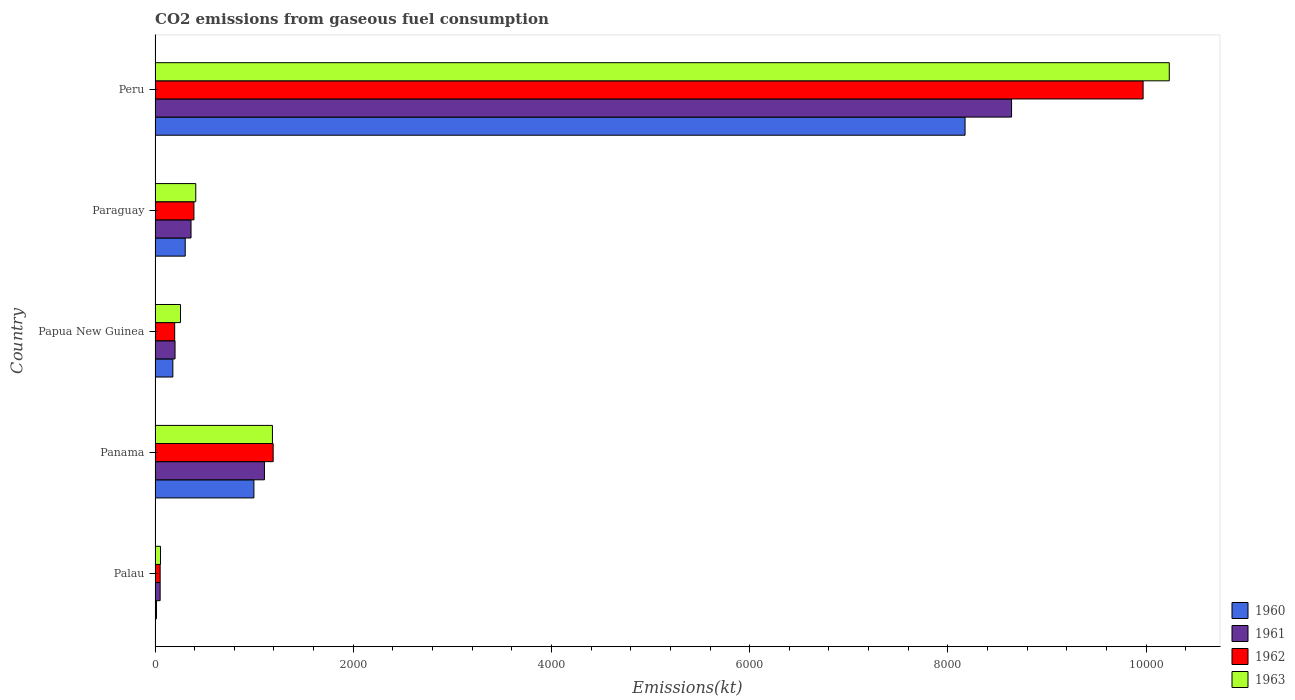Are the number of bars on each tick of the Y-axis equal?
Offer a terse response. Yes. How many bars are there on the 1st tick from the top?
Make the answer very short. 4. How many bars are there on the 4th tick from the bottom?
Offer a very short reply. 4. What is the label of the 4th group of bars from the top?
Your answer should be compact. Panama. What is the amount of CO2 emitted in 1960 in Peru?
Give a very brief answer. 8173.74. Across all countries, what is the maximum amount of CO2 emitted in 1962?
Provide a short and direct response. 9970.57. Across all countries, what is the minimum amount of CO2 emitted in 1963?
Offer a terse response. 55.01. In which country was the amount of CO2 emitted in 1961 maximum?
Your answer should be compact. Peru. In which country was the amount of CO2 emitted in 1961 minimum?
Your answer should be compact. Palau. What is the total amount of CO2 emitted in 1963 in the graph?
Provide a short and direct response. 1.21e+04. What is the difference between the amount of CO2 emitted in 1961 in Palau and that in Papua New Guinea?
Keep it short and to the point. -150.35. What is the difference between the amount of CO2 emitted in 1960 in Palau and the amount of CO2 emitted in 1962 in Peru?
Keep it short and to the point. -9955.91. What is the average amount of CO2 emitted in 1963 per country?
Make the answer very short. 2428.29. What is the difference between the amount of CO2 emitted in 1963 and amount of CO2 emitted in 1961 in Panama?
Ensure brevity in your answer.  80.67. In how many countries, is the amount of CO2 emitted in 1961 greater than 1600 kt?
Offer a very short reply. 1. What is the ratio of the amount of CO2 emitted in 1962 in Panama to that in Paraguay?
Make the answer very short. 3.04. Is the difference between the amount of CO2 emitted in 1963 in Panama and Papua New Guinea greater than the difference between the amount of CO2 emitted in 1961 in Panama and Papua New Guinea?
Provide a succinct answer. Yes. What is the difference between the highest and the second highest amount of CO2 emitted in 1963?
Offer a very short reply. 9050.16. What is the difference between the highest and the lowest amount of CO2 emitted in 1961?
Your answer should be very brief. 8591.78. Is the sum of the amount of CO2 emitted in 1961 in Palau and Peru greater than the maximum amount of CO2 emitted in 1963 across all countries?
Provide a succinct answer. No. What does the 4th bar from the top in Palau represents?
Give a very brief answer. 1960. Is it the case that in every country, the sum of the amount of CO2 emitted in 1961 and amount of CO2 emitted in 1962 is greater than the amount of CO2 emitted in 1963?
Keep it short and to the point. Yes. Are all the bars in the graph horizontal?
Make the answer very short. Yes. How many countries are there in the graph?
Offer a terse response. 5. Are the values on the major ticks of X-axis written in scientific E-notation?
Offer a terse response. No. Does the graph contain grids?
Provide a succinct answer. No. How many legend labels are there?
Provide a succinct answer. 4. What is the title of the graph?
Your answer should be compact. CO2 emissions from gaseous fuel consumption. Does "1982" appear as one of the legend labels in the graph?
Provide a succinct answer. No. What is the label or title of the X-axis?
Offer a very short reply. Emissions(kt). What is the label or title of the Y-axis?
Offer a terse response. Country. What is the Emissions(kt) in 1960 in Palau?
Your answer should be very brief. 14.67. What is the Emissions(kt) of 1961 in Palau?
Give a very brief answer. 51.34. What is the Emissions(kt) of 1962 in Palau?
Offer a terse response. 51.34. What is the Emissions(kt) in 1963 in Palau?
Give a very brief answer. 55.01. What is the Emissions(kt) in 1960 in Panama?
Your answer should be very brief. 997.42. What is the Emissions(kt) of 1961 in Panama?
Give a very brief answer. 1103.77. What is the Emissions(kt) of 1962 in Panama?
Provide a succinct answer. 1191.78. What is the Emissions(kt) of 1963 in Panama?
Your response must be concise. 1184.44. What is the Emissions(kt) in 1960 in Papua New Guinea?
Your answer should be compact. 179.68. What is the Emissions(kt) of 1961 in Papua New Guinea?
Make the answer very short. 201.69. What is the Emissions(kt) in 1962 in Papua New Guinea?
Keep it short and to the point. 198.02. What is the Emissions(kt) of 1963 in Papua New Guinea?
Keep it short and to the point. 256.69. What is the Emissions(kt) in 1960 in Paraguay?
Offer a very short reply. 304.36. What is the Emissions(kt) of 1961 in Paraguay?
Offer a very short reply. 363.03. What is the Emissions(kt) of 1962 in Paraguay?
Make the answer very short. 392.37. What is the Emissions(kt) of 1963 in Paraguay?
Your answer should be very brief. 410.7. What is the Emissions(kt) in 1960 in Peru?
Make the answer very short. 8173.74. What is the Emissions(kt) of 1961 in Peru?
Your answer should be very brief. 8643.12. What is the Emissions(kt) of 1962 in Peru?
Your response must be concise. 9970.57. What is the Emissions(kt) of 1963 in Peru?
Give a very brief answer. 1.02e+04. Across all countries, what is the maximum Emissions(kt) in 1960?
Your answer should be very brief. 8173.74. Across all countries, what is the maximum Emissions(kt) of 1961?
Give a very brief answer. 8643.12. Across all countries, what is the maximum Emissions(kt) of 1962?
Keep it short and to the point. 9970.57. Across all countries, what is the maximum Emissions(kt) of 1963?
Make the answer very short. 1.02e+04. Across all countries, what is the minimum Emissions(kt) of 1960?
Offer a terse response. 14.67. Across all countries, what is the minimum Emissions(kt) in 1961?
Provide a short and direct response. 51.34. Across all countries, what is the minimum Emissions(kt) of 1962?
Your response must be concise. 51.34. Across all countries, what is the minimum Emissions(kt) in 1963?
Offer a terse response. 55.01. What is the total Emissions(kt) in 1960 in the graph?
Provide a succinct answer. 9669.88. What is the total Emissions(kt) in 1961 in the graph?
Your answer should be very brief. 1.04e+04. What is the total Emissions(kt) of 1962 in the graph?
Your answer should be compact. 1.18e+04. What is the total Emissions(kt) of 1963 in the graph?
Provide a short and direct response. 1.21e+04. What is the difference between the Emissions(kt) of 1960 in Palau and that in Panama?
Give a very brief answer. -982.76. What is the difference between the Emissions(kt) of 1961 in Palau and that in Panama?
Provide a short and direct response. -1052.43. What is the difference between the Emissions(kt) in 1962 in Palau and that in Panama?
Your answer should be compact. -1140.44. What is the difference between the Emissions(kt) in 1963 in Palau and that in Panama?
Give a very brief answer. -1129.44. What is the difference between the Emissions(kt) in 1960 in Palau and that in Papua New Guinea?
Keep it short and to the point. -165.01. What is the difference between the Emissions(kt) of 1961 in Palau and that in Papua New Guinea?
Offer a terse response. -150.35. What is the difference between the Emissions(kt) in 1962 in Palau and that in Papua New Guinea?
Make the answer very short. -146.68. What is the difference between the Emissions(kt) in 1963 in Palau and that in Papua New Guinea?
Provide a succinct answer. -201.69. What is the difference between the Emissions(kt) of 1960 in Palau and that in Paraguay?
Ensure brevity in your answer.  -289.69. What is the difference between the Emissions(kt) of 1961 in Palau and that in Paraguay?
Ensure brevity in your answer.  -311.69. What is the difference between the Emissions(kt) of 1962 in Palau and that in Paraguay?
Offer a terse response. -341.03. What is the difference between the Emissions(kt) in 1963 in Palau and that in Paraguay?
Ensure brevity in your answer.  -355.7. What is the difference between the Emissions(kt) of 1960 in Palau and that in Peru?
Offer a terse response. -8159.07. What is the difference between the Emissions(kt) of 1961 in Palau and that in Peru?
Provide a short and direct response. -8591.78. What is the difference between the Emissions(kt) in 1962 in Palau and that in Peru?
Provide a short and direct response. -9919.24. What is the difference between the Emissions(kt) of 1963 in Palau and that in Peru?
Keep it short and to the point. -1.02e+04. What is the difference between the Emissions(kt) of 1960 in Panama and that in Papua New Guinea?
Keep it short and to the point. 817.74. What is the difference between the Emissions(kt) in 1961 in Panama and that in Papua New Guinea?
Your response must be concise. 902.08. What is the difference between the Emissions(kt) in 1962 in Panama and that in Papua New Guinea?
Provide a succinct answer. 993.76. What is the difference between the Emissions(kt) in 1963 in Panama and that in Papua New Guinea?
Provide a succinct answer. 927.75. What is the difference between the Emissions(kt) in 1960 in Panama and that in Paraguay?
Offer a terse response. 693.06. What is the difference between the Emissions(kt) of 1961 in Panama and that in Paraguay?
Your answer should be very brief. 740.73. What is the difference between the Emissions(kt) of 1962 in Panama and that in Paraguay?
Offer a terse response. 799.41. What is the difference between the Emissions(kt) in 1963 in Panama and that in Paraguay?
Provide a short and direct response. 773.74. What is the difference between the Emissions(kt) in 1960 in Panama and that in Peru?
Provide a succinct answer. -7176.32. What is the difference between the Emissions(kt) of 1961 in Panama and that in Peru?
Make the answer very short. -7539.35. What is the difference between the Emissions(kt) in 1962 in Panama and that in Peru?
Make the answer very short. -8778.8. What is the difference between the Emissions(kt) in 1963 in Panama and that in Peru?
Provide a short and direct response. -9050.16. What is the difference between the Emissions(kt) in 1960 in Papua New Guinea and that in Paraguay?
Give a very brief answer. -124.68. What is the difference between the Emissions(kt) of 1961 in Papua New Guinea and that in Paraguay?
Your answer should be very brief. -161.35. What is the difference between the Emissions(kt) of 1962 in Papua New Guinea and that in Paraguay?
Keep it short and to the point. -194.35. What is the difference between the Emissions(kt) of 1963 in Papua New Guinea and that in Paraguay?
Ensure brevity in your answer.  -154.01. What is the difference between the Emissions(kt) in 1960 in Papua New Guinea and that in Peru?
Your response must be concise. -7994.06. What is the difference between the Emissions(kt) of 1961 in Papua New Guinea and that in Peru?
Ensure brevity in your answer.  -8441.43. What is the difference between the Emissions(kt) in 1962 in Papua New Guinea and that in Peru?
Provide a succinct answer. -9772.56. What is the difference between the Emissions(kt) in 1963 in Papua New Guinea and that in Peru?
Give a very brief answer. -9977.91. What is the difference between the Emissions(kt) of 1960 in Paraguay and that in Peru?
Provide a succinct answer. -7869.38. What is the difference between the Emissions(kt) of 1961 in Paraguay and that in Peru?
Make the answer very short. -8280.09. What is the difference between the Emissions(kt) in 1962 in Paraguay and that in Peru?
Your response must be concise. -9578.2. What is the difference between the Emissions(kt) in 1963 in Paraguay and that in Peru?
Provide a short and direct response. -9823.89. What is the difference between the Emissions(kt) of 1960 in Palau and the Emissions(kt) of 1961 in Panama?
Offer a terse response. -1089.1. What is the difference between the Emissions(kt) in 1960 in Palau and the Emissions(kt) in 1962 in Panama?
Your answer should be compact. -1177.11. What is the difference between the Emissions(kt) in 1960 in Palau and the Emissions(kt) in 1963 in Panama?
Give a very brief answer. -1169.77. What is the difference between the Emissions(kt) of 1961 in Palau and the Emissions(kt) of 1962 in Panama?
Your answer should be compact. -1140.44. What is the difference between the Emissions(kt) of 1961 in Palau and the Emissions(kt) of 1963 in Panama?
Your answer should be compact. -1133.1. What is the difference between the Emissions(kt) of 1962 in Palau and the Emissions(kt) of 1963 in Panama?
Your answer should be very brief. -1133.1. What is the difference between the Emissions(kt) in 1960 in Palau and the Emissions(kt) in 1961 in Papua New Guinea?
Your answer should be very brief. -187.02. What is the difference between the Emissions(kt) of 1960 in Palau and the Emissions(kt) of 1962 in Papua New Guinea?
Your answer should be compact. -183.35. What is the difference between the Emissions(kt) in 1960 in Palau and the Emissions(kt) in 1963 in Papua New Guinea?
Your response must be concise. -242.02. What is the difference between the Emissions(kt) of 1961 in Palau and the Emissions(kt) of 1962 in Papua New Guinea?
Make the answer very short. -146.68. What is the difference between the Emissions(kt) in 1961 in Palau and the Emissions(kt) in 1963 in Papua New Guinea?
Make the answer very short. -205.35. What is the difference between the Emissions(kt) of 1962 in Palau and the Emissions(kt) of 1963 in Papua New Guinea?
Ensure brevity in your answer.  -205.35. What is the difference between the Emissions(kt) in 1960 in Palau and the Emissions(kt) in 1961 in Paraguay?
Your response must be concise. -348.37. What is the difference between the Emissions(kt) of 1960 in Palau and the Emissions(kt) of 1962 in Paraguay?
Offer a very short reply. -377.7. What is the difference between the Emissions(kt) of 1960 in Palau and the Emissions(kt) of 1963 in Paraguay?
Offer a very short reply. -396.04. What is the difference between the Emissions(kt) of 1961 in Palau and the Emissions(kt) of 1962 in Paraguay?
Make the answer very short. -341.03. What is the difference between the Emissions(kt) in 1961 in Palau and the Emissions(kt) in 1963 in Paraguay?
Provide a succinct answer. -359.37. What is the difference between the Emissions(kt) in 1962 in Palau and the Emissions(kt) in 1963 in Paraguay?
Offer a terse response. -359.37. What is the difference between the Emissions(kt) of 1960 in Palau and the Emissions(kt) of 1961 in Peru?
Ensure brevity in your answer.  -8628.45. What is the difference between the Emissions(kt) in 1960 in Palau and the Emissions(kt) in 1962 in Peru?
Offer a terse response. -9955.91. What is the difference between the Emissions(kt) in 1960 in Palau and the Emissions(kt) in 1963 in Peru?
Your response must be concise. -1.02e+04. What is the difference between the Emissions(kt) in 1961 in Palau and the Emissions(kt) in 1962 in Peru?
Keep it short and to the point. -9919.24. What is the difference between the Emissions(kt) of 1961 in Palau and the Emissions(kt) of 1963 in Peru?
Your response must be concise. -1.02e+04. What is the difference between the Emissions(kt) in 1962 in Palau and the Emissions(kt) in 1963 in Peru?
Your answer should be very brief. -1.02e+04. What is the difference between the Emissions(kt) of 1960 in Panama and the Emissions(kt) of 1961 in Papua New Guinea?
Ensure brevity in your answer.  795.74. What is the difference between the Emissions(kt) of 1960 in Panama and the Emissions(kt) of 1962 in Papua New Guinea?
Make the answer very short. 799.41. What is the difference between the Emissions(kt) of 1960 in Panama and the Emissions(kt) of 1963 in Papua New Guinea?
Offer a terse response. 740.73. What is the difference between the Emissions(kt) of 1961 in Panama and the Emissions(kt) of 1962 in Papua New Guinea?
Ensure brevity in your answer.  905.75. What is the difference between the Emissions(kt) of 1961 in Panama and the Emissions(kt) of 1963 in Papua New Guinea?
Offer a terse response. 847.08. What is the difference between the Emissions(kt) of 1962 in Panama and the Emissions(kt) of 1963 in Papua New Guinea?
Make the answer very short. 935.09. What is the difference between the Emissions(kt) in 1960 in Panama and the Emissions(kt) in 1961 in Paraguay?
Provide a succinct answer. 634.39. What is the difference between the Emissions(kt) of 1960 in Panama and the Emissions(kt) of 1962 in Paraguay?
Give a very brief answer. 605.05. What is the difference between the Emissions(kt) of 1960 in Panama and the Emissions(kt) of 1963 in Paraguay?
Provide a short and direct response. 586.72. What is the difference between the Emissions(kt) in 1961 in Panama and the Emissions(kt) in 1962 in Paraguay?
Your answer should be very brief. 711.4. What is the difference between the Emissions(kt) of 1961 in Panama and the Emissions(kt) of 1963 in Paraguay?
Offer a terse response. 693.06. What is the difference between the Emissions(kt) of 1962 in Panama and the Emissions(kt) of 1963 in Paraguay?
Your answer should be compact. 781.07. What is the difference between the Emissions(kt) in 1960 in Panama and the Emissions(kt) in 1961 in Peru?
Provide a succinct answer. -7645.69. What is the difference between the Emissions(kt) of 1960 in Panama and the Emissions(kt) of 1962 in Peru?
Offer a very short reply. -8973.15. What is the difference between the Emissions(kt) in 1960 in Panama and the Emissions(kt) in 1963 in Peru?
Provide a succinct answer. -9237.17. What is the difference between the Emissions(kt) of 1961 in Panama and the Emissions(kt) of 1962 in Peru?
Your answer should be very brief. -8866.81. What is the difference between the Emissions(kt) of 1961 in Panama and the Emissions(kt) of 1963 in Peru?
Keep it short and to the point. -9130.83. What is the difference between the Emissions(kt) of 1962 in Panama and the Emissions(kt) of 1963 in Peru?
Ensure brevity in your answer.  -9042.82. What is the difference between the Emissions(kt) of 1960 in Papua New Guinea and the Emissions(kt) of 1961 in Paraguay?
Provide a succinct answer. -183.35. What is the difference between the Emissions(kt) in 1960 in Papua New Guinea and the Emissions(kt) in 1962 in Paraguay?
Your answer should be compact. -212.69. What is the difference between the Emissions(kt) in 1960 in Papua New Guinea and the Emissions(kt) in 1963 in Paraguay?
Your answer should be very brief. -231.02. What is the difference between the Emissions(kt) in 1961 in Papua New Guinea and the Emissions(kt) in 1962 in Paraguay?
Your answer should be very brief. -190.68. What is the difference between the Emissions(kt) of 1961 in Papua New Guinea and the Emissions(kt) of 1963 in Paraguay?
Your response must be concise. -209.02. What is the difference between the Emissions(kt) in 1962 in Papua New Guinea and the Emissions(kt) in 1963 in Paraguay?
Keep it short and to the point. -212.69. What is the difference between the Emissions(kt) in 1960 in Papua New Guinea and the Emissions(kt) in 1961 in Peru?
Make the answer very short. -8463.44. What is the difference between the Emissions(kt) of 1960 in Papua New Guinea and the Emissions(kt) of 1962 in Peru?
Give a very brief answer. -9790.89. What is the difference between the Emissions(kt) in 1960 in Papua New Guinea and the Emissions(kt) in 1963 in Peru?
Make the answer very short. -1.01e+04. What is the difference between the Emissions(kt) of 1961 in Papua New Guinea and the Emissions(kt) of 1962 in Peru?
Ensure brevity in your answer.  -9768.89. What is the difference between the Emissions(kt) in 1961 in Papua New Guinea and the Emissions(kt) in 1963 in Peru?
Ensure brevity in your answer.  -1.00e+04. What is the difference between the Emissions(kt) in 1962 in Papua New Guinea and the Emissions(kt) in 1963 in Peru?
Ensure brevity in your answer.  -1.00e+04. What is the difference between the Emissions(kt) of 1960 in Paraguay and the Emissions(kt) of 1961 in Peru?
Offer a terse response. -8338.76. What is the difference between the Emissions(kt) in 1960 in Paraguay and the Emissions(kt) in 1962 in Peru?
Offer a terse response. -9666.21. What is the difference between the Emissions(kt) of 1960 in Paraguay and the Emissions(kt) of 1963 in Peru?
Give a very brief answer. -9930.24. What is the difference between the Emissions(kt) in 1961 in Paraguay and the Emissions(kt) in 1962 in Peru?
Offer a terse response. -9607.54. What is the difference between the Emissions(kt) of 1961 in Paraguay and the Emissions(kt) of 1963 in Peru?
Make the answer very short. -9871.56. What is the difference between the Emissions(kt) of 1962 in Paraguay and the Emissions(kt) of 1963 in Peru?
Provide a succinct answer. -9842.23. What is the average Emissions(kt) in 1960 per country?
Give a very brief answer. 1933.98. What is the average Emissions(kt) of 1961 per country?
Your response must be concise. 2072.59. What is the average Emissions(kt) of 1962 per country?
Give a very brief answer. 2360.81. What is the average Emissions(kt) in 1963 per country?
Provide a succinct answer. 2428.29. What is the difference between the Emissions(kt) in 1960 and Emissions(kt) in 1961 in Palau?
Offer a terse response. -36.67. What is the difference between the Emissions(kt) of 1960 and Emissions(kt) of 1962 in Palau?
Make the answer very short. -36.67. What is the difference between the Emissions(kt) of 1960 and Emissions(kt) of 1963 in Palau?
Your answer should be compact. -40.34. What is the difference between the Emissions(kt) in 1961 and Emissions(kt) in 1963 in Palau?
Ensure brevity in your answer.  -3.67. What is the difference between the Emissions(kt) of 1962 and Emissions(kt) of 1963 in Palau?
Provide a short and direct response. -3.67. What is the difference between the Emissions(kt) of 1960 and Emissions(kt) of 1961 in Panama?
Give a very brief answer. -106.34. What is the difference between the Emissions(kt) of 1960 and Emissions(kt) of 1962 in Panama?
Keep it short and to the point. -194.35. What is the difference between the Emissions(kt) in 1960 and Emissions(kt) in 1963 in Panama?
Ensure brevity in your answer.  -187.02. What is the difference between the Emissions(kt) of 1961 and Emissions(kt) of 1962 in Panama?
Keep it short and to the point. -88.01. What is the difference between the Emissions(kt) in 1961 and Emissions(kt) in 1963 in Panama?
Your response must be concise. -80.67. What is the difference between the Emissions(kt) in 1962 and Emissions(kt) in 1963 in Panama?
Provide a short and direct response. 7.33. What is the difference between the Emissions(kt) of 1960 and Emissions(kt) of 1961 in Papua New Guinea?
Your response must be concise. -22. What is the difference between the Emissions(kt) in 1960 and Emissions(kt) in 1962 in Papua New Guinea?
Give a very brief answer. -18.34. What is the difference between the Emissions(kt) in 1960 and Emissions(kt) in 1963 in Papua New Guinea?
Make the answer very short. -77.01. What is the difference between the Emissions(kt) of 1961 and Emissions(kt) of 1962 in Papua New Guinea?
Your answer should be compact. 3.67. What is the difference between the Emissions(kt) of 1961 and Emissions(kt) of 1963 in Papua New Guinea?
Offer a terse response. -55.01. What is the difference between the Emissions(kt) in 1962 and Emissions(kt) in 1963 in Papua New Guinea?
Your response must be concise. -58.67. What is the difference between the Emissions(kt) of 1960 and Emissions(kt) of 1961 in Paraguay?
Your response must be concise. -58.67. What is the difference between the Emissions(kt) in 1960 and Emissions(kt) in 1962 in Paraguay?
Provide a short and direct response. -88.01. What is the difference between the Emissions(kt) of 1960 and Emissions(kt) of 1963 in Paraguay?
Ensure brevity in your answer.  -106.34. What is the difference between the Emissions(kt) in 1961 and Emissions(kt) in 1962 in Paraguay?
Give a very brief answer. -29.34. What is the difference between the Emissions(kt) in 1961 and Emissions(kt) in 1963 in Paraguay?
Offer a very short reply. -47.67. What is the difference between the Emissions(kt) of 1962 and Emissions(kt) of 1963 in Paraguay?
Keep it short and to the point. -18.34. What is the difference between the Emissions(kt) in 1960 and Emissions(kt) in 1961 in Peru?
Provide a short and direct response. -469.38. What is the difference between the Emissions(kt) of 1960 and Emissions(kt) of 1962 in Peru?
Offer a terse response. -1796.83. What is the difference between the Emissions(kt) of 1960 and Emissions(kt) of 1963 in Peru?
Your answer should be compact. -2060.85. What is the difference between the Emissions(kt) in 1961 and Emissions(kt) in 1962 in Peru?
Offer a very short reply. -1327.45. What is the difference between the Emissions(kt) of 1961 and Emissions(kt) of 1963 in Peru?
Your response must be concise. -1591.48. What is the difference between the Emissions(kt) of 1962 and Emissions(kt) of 1963 in Peru?
Ensure brevity in your answer.  -264.02. What is the ratio of the Emissions(kt) in 1960 in Palau to that in Panama?
Make the answer very short. 0.01. What is the ratio of the Emissions(kt) in 1961 in Palau to that in Panama?
Keep it short and to the point. 0.05. What is the ratio of the Emissions(kt) in 1962 in Palau to that in Panama?
Offer a terse response. 0.04. What is the ratio of the Emissions(kt) of 1963 in Palau to that in Panama?
Offer a terse response. 0.05. What is the ratio of the Emissions(kt) in 1960 in Palau to that in Papua New Guinea?
Offer a terse response. 0.08. What is the ratio of the Emissions(kt) in 1961 in Palau to that in Papua New Guinea?
Your answer should be very brief. 0.25. What is the ratio of the Emissions(kt) in 1962 in Palau to that in Papua New Guinea?
Your answer should be compact. 0.26. What is the ratio of the Emissions(kt) in 1963 in Palau to that in Papua New Guinea?
Ensure brevity in your answer.  0.21. What is the ratio of the Emissions(kt) of 1960 in Palau to that in Paraguay?
Keep it short and to the point. 0.05. What is the ratio of the Emissions(kt) of 1961 in Palau to that in Paraguay?
Your answer should be very brief. 0.14. What is the ratio of the Emissions(kt) in 1962 in Palau to that in Paraguay?
Your answer should be compact. 0.13. What is the ratio of the Emissions(kt) of 1963 in Palau to that in Paraguay?
Provide a succinct answer. 0.13. What is the ratio of the Emissions(kt) of 1960 in Palau to that in Peru?
Give a very brief answer. 0. What is the ratio of the Emissions(kt) of 1961 in Palau to that in Peru?
Provide a succinct answer. 0.01. What is the ratio of the Emissions(kt) in 1962 in Palau to that in Peru?
Provide a short and direct response. 0.01. What is the ratio of the Emissions(kt) of 1963 in Palau to that in Peru?
Your answer should be very brief. 0.01. What is the ratio of the Emissions(kt) of 1960 in Panama to that in Papua New Guinea?
Give a very brief answer. 5.55. What is the ratio of the Emissions(kt) in 1961 in Panama to that in Papua New Guinea?
Your response must be concise. 5.47. What is the ratio of the Emissions(kt) of 1962 in Panama to that in Papua New Guinea?
Offer a terse response. 6.02. What is the ratio of the Emissions(kt) in 1963 in Panama to that in Papua New Guinea?
Provide a short and direct response. 4.61. What is the ratio of the Emissions(kt) in 1960 in Panama to that in Paraguay?
Give a very brief answer. 3.28. What is the ratio of the Emissions(kt) in 1961 in Panama to that in Paraguay?
Offer a very short reply. 3.04. What is the ratio of the Emissions(kt) of 1962 in Panama to that in Paraguay?
Your answer should be very brief. 3.04. What is the ratio of the Emissions(kt) of 1963 in Panama to that in Paraguay?
Offer a very short reply. 2.88. What is the ratio of the Emissions(kt) of 1960 in Panama to that in Peru?
Provide a succinct answer. 0.12. What is the ratio of the Emissions(kt) in 1961 in Panama to that in Peru?
Offer a terse response. 0.13. What is the ratio of the Emissions(kt) of 1962 in Panama to that in Peru?
Offer a terse response. 0.12. What is the ratio of the Emissions(kt) of 1963 in Panama to that in Peru?
Provide a short and direct response. 0.12. What is the ratio of the Emissions(kt) in 1960 in Papua New Guinea to that in Paraguay?
Your response must be concise. 0.59. What is the ratio of the Emissions(kt) in 1961 in Papua New Guinea to that in Paraguay?
Offer a very short reply. 0.56. What is the ratio of the Emissions(kt) in 1962 in Papua New Guinea to that in Paraguay?
Offer a terse response. 0.5. What is the ratio of the Emissions(kt) in 1963 in Papua New Guinea to that in Paraguay?
Ensure brevity in your answer.  0.62. What is the ratio of the Emissions(kt) of 1960 in Papua New Guinea to that in Peru?
Ensure brevity in your answer.  0.02. What is the ratio of the Emissions(kt) in 1961 in Papua New Guinea to that in Peru?
Provide a short and direct response. 0.02. What is the ratio of the Emissions(kt) in 1962 in Papua New Guinea to that in Peru?
Provide a succinct answer. 0.02. What is the ratio of the Emissions(kt) in 1963 in Papua New Guinea to that in Peru?
Provide a succinct answer. 0.03. What is the ratio of the Emissions(kt) in 1960 in Paraguay to that in Peru?
Give a very brief answer. 0.04. What is the ratio of the Emissions(kt) of 1961 in Paraguay to that in Peru?
Keep it short and to the point. 0.04. What is the ratio of the Emissions(kt) in 1962 in Paraguay to that in Peru?
Give a very brief answer. 0.04. What is the ratio of the Emissions(kt) in 1963 in Paraguay to that in Peru?
Offer a terse response. 0.04. What is the difference between the highest and the second highest Emissions(kt) of 1960?
Provide a succinct answer. 7176.32. What is the difference between the highest and the second highest Emissions(kt) in 1961?
Ensure brevity in your answer.  7539.35. What is the difference between the highest and the second highest Emissions(kt) in 1962?
Provide a short and direct response. 8778.8. What is the difference between the highest and the second highest Emissions(kt) of 1963?
Keep it short and to the point. 9050.16. What is the difference between the highest and the lowest Emissions(kt) in 1960?
Your answer should be compact. 8159.07. What is the difference between the highest and the lowest Emissions(kt) of 1961?
Make the answer very short. 8591.78. What is the difference between the highest and the lowest Emissions(kt) in 1962?
Offer a very short reply. 9919.24. What is the difference between the highest and the lowest Emissions(kt) in 1963?
Provide a succinct answer. 1.02e+04. 